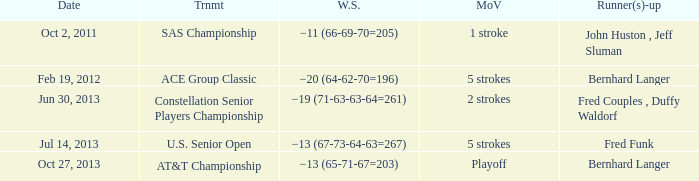Which Date has a Margin of victory of 5 strokes, and a Winning score of −13 (67-73-64-63=267)? Jul 14, 2013. 